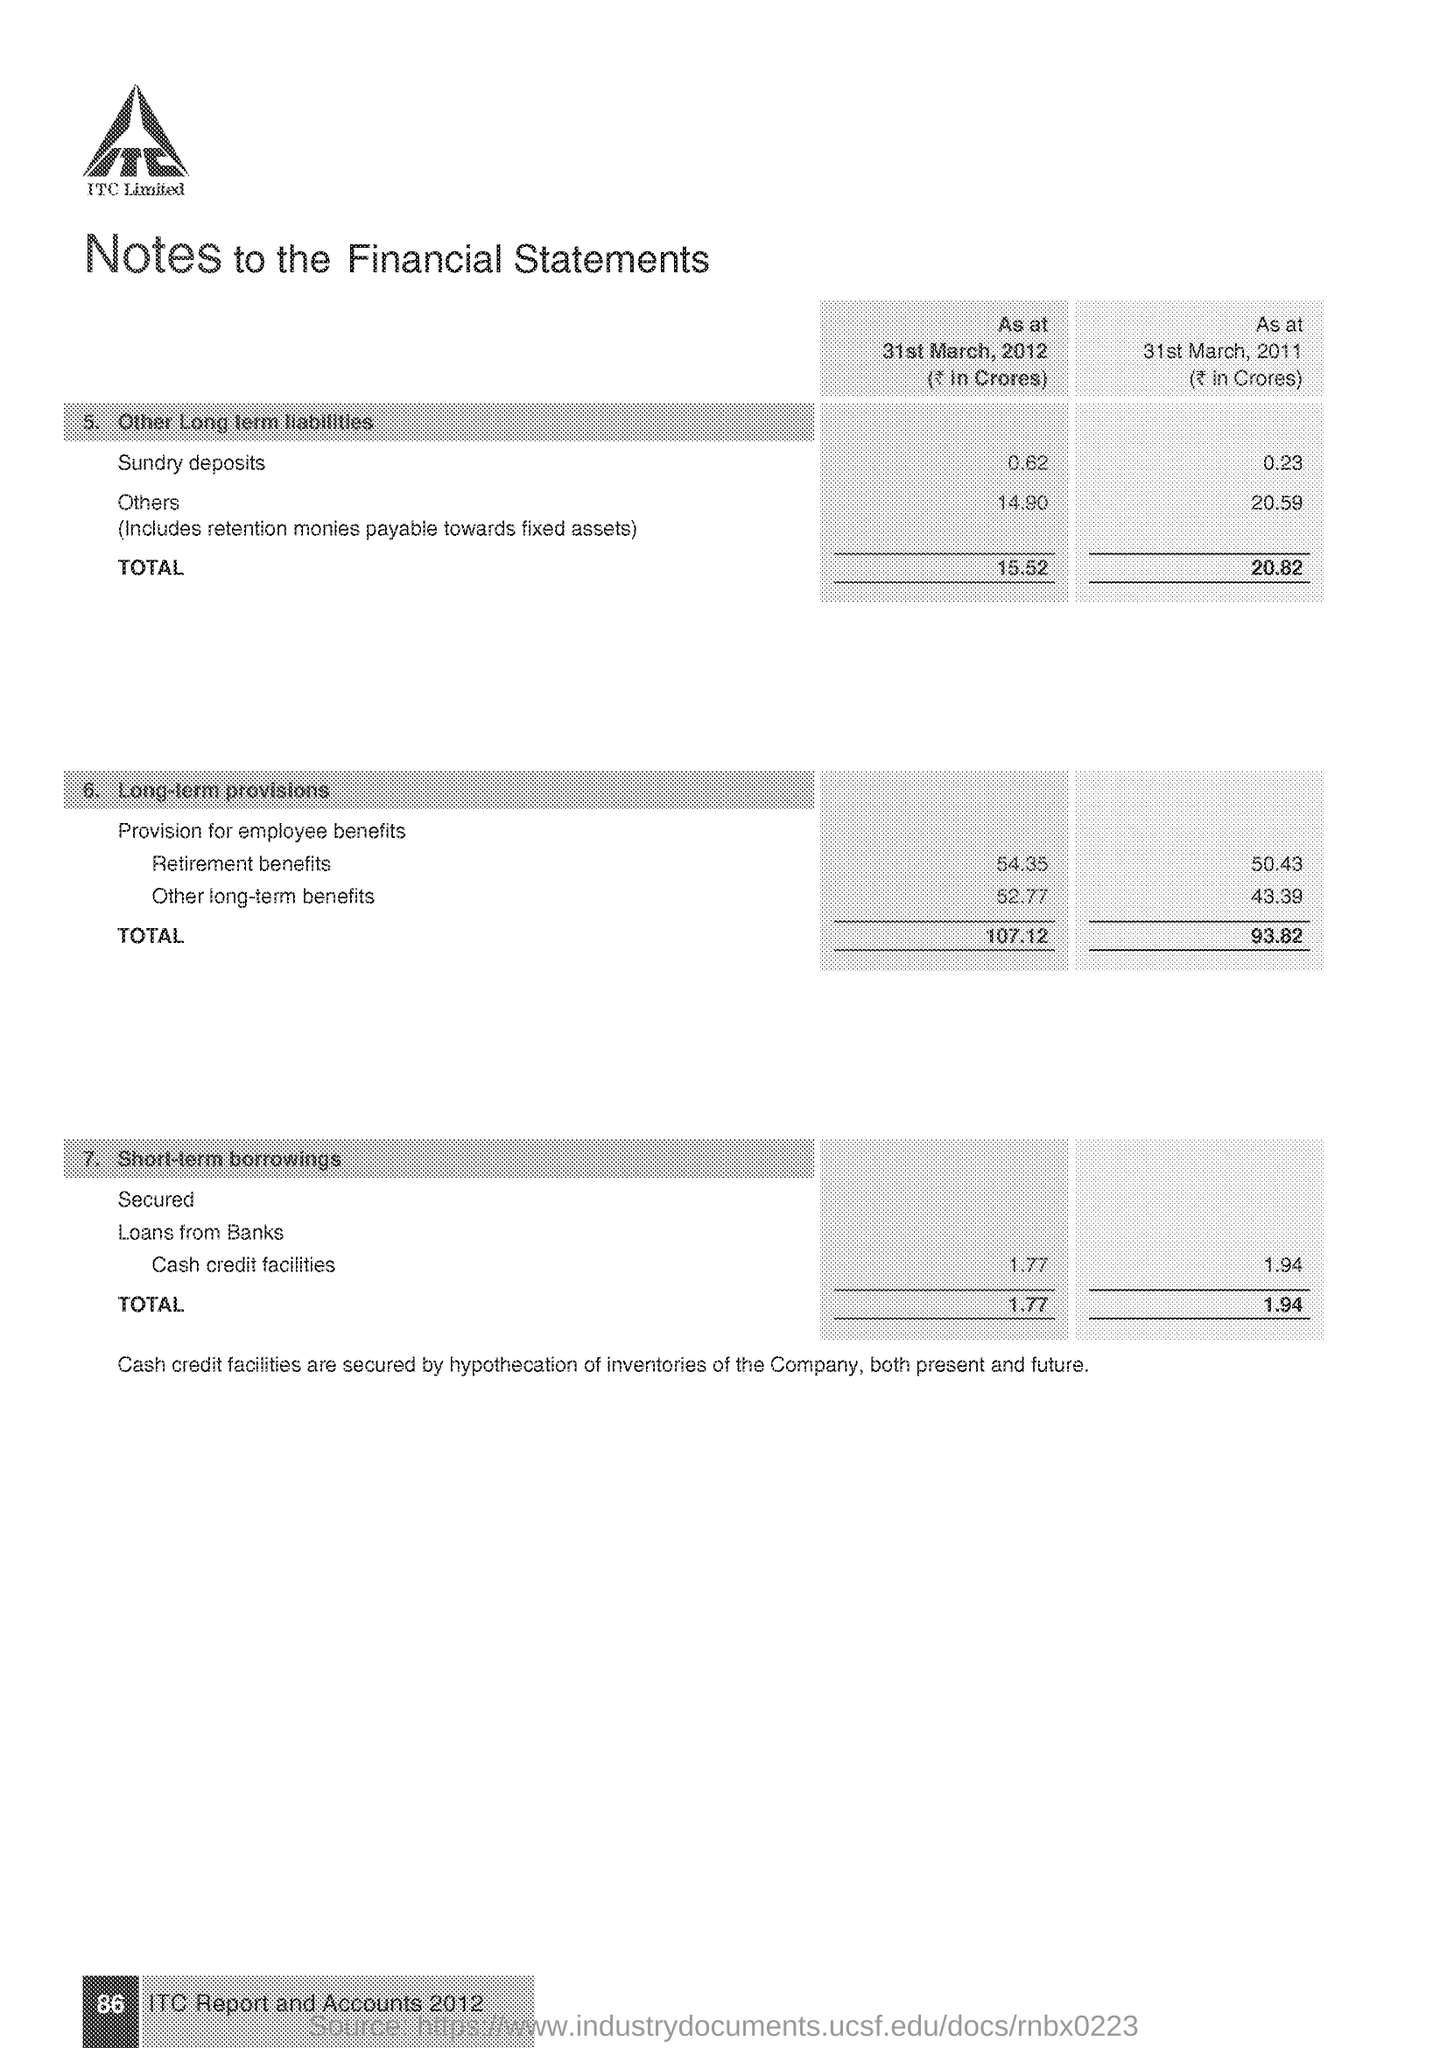Indicate a few pertinent items in this graphic. The total of Other Long Term Liabilities as at March 31, 2011 was 20.82 billion Indian Rupees. As of March 31, 2011, the total short-term borrowings were 1.94 billion Indian Rupees. The page number mentioned in this document is 86. As of March 31, 2012, the total amount of Other Long Term Liabilities was ₹15,520 million. As of March 31st, 2012, the total short-term borrowings were 1.77 billion Indian rupees. 